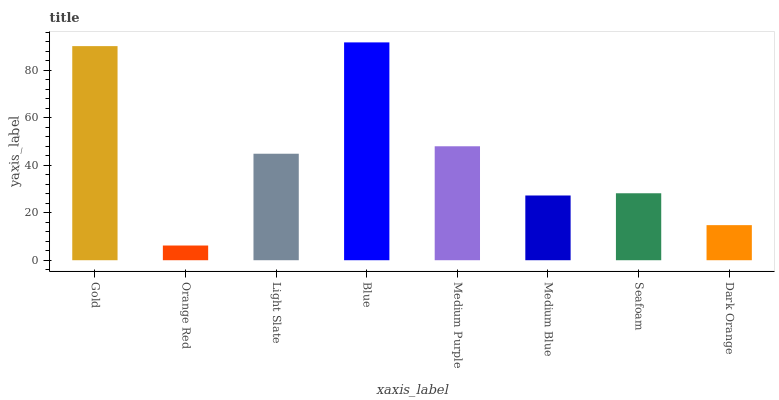Is Orange Red the minimum?
Answer yes or no. Yes. Is Blue the maximum?
Answer yes or no. Yes. Is Light Slate the minimum?
Answer yes or no. No. Is Light Slate the maximum?
Answer yes or no. No. Is Light Slate greater than Orange Red?
Answer yes or no. Yes. Is Orange Red less than Light Slate?
Answer yes or no. Yes. Is Orange Red greater than Light Slate?
Answer yes or no. No. Is Light Slate less than Orange Red?
Answer yes or no. No. Is Light Slate the high median?
Answer yes or no. Yes. Is Seafoam the low median?
Answer yes or no. Yes. Is Blue the high median?
Answer yes or no. No. Is Dark Orange the low median?
Answer yes or no. No. 